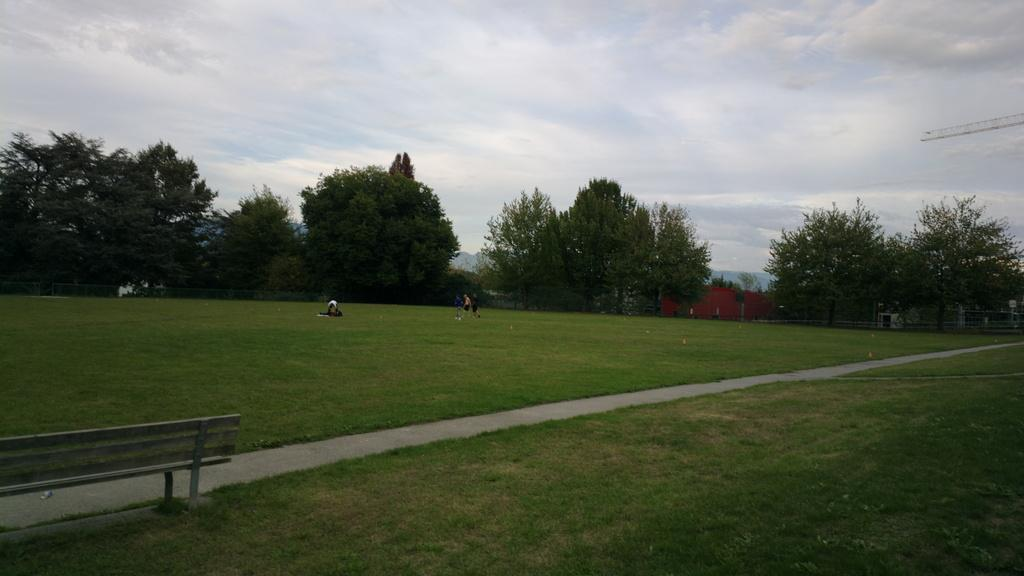What type of furniture is located on the left side of the image? There is a bench chair on the left side of the image. What is the location of the scene in the image? The setting appears to be a garden. What can be seen in the background of the image? There are trees visible in the background. How would you describe the weather in the image? The sky is cloudy in the image. How many chickens are present in the image? There are no chickens present in the image. What type of parent is sitting on the bench chair in the image? There is no parent sitting on the bench chair in the image. 